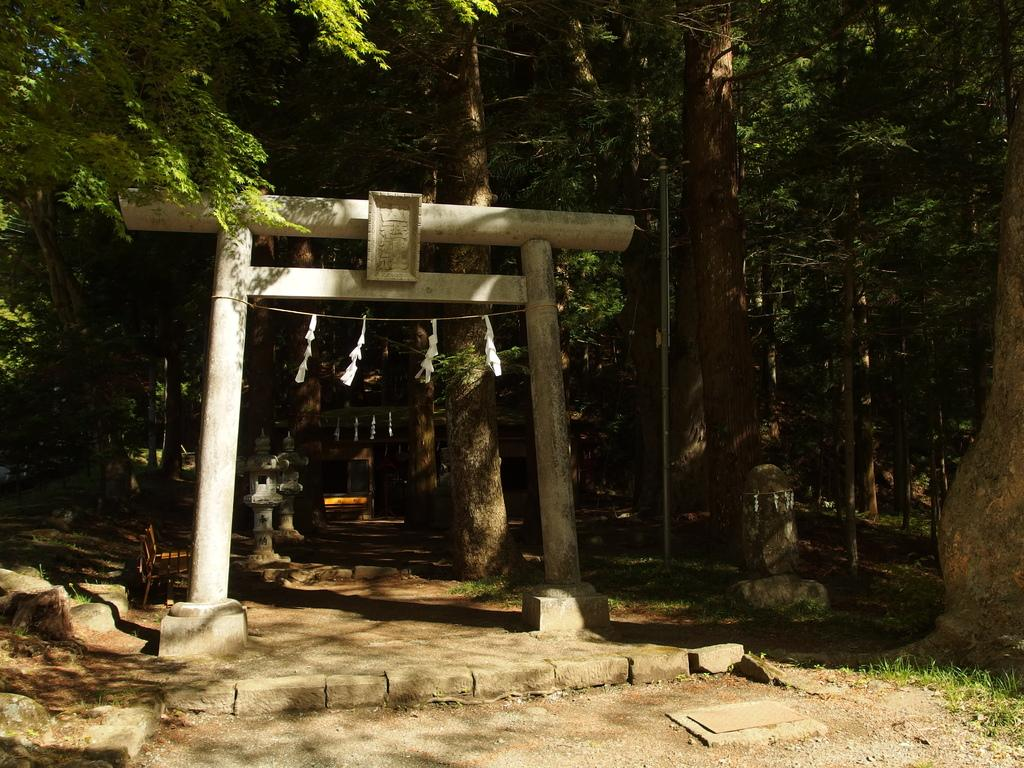What type of structures can be seen in the image? There are poles in the image. What else is present in the image besides the poles? There are objects and trees in the image. What is the ground covered with in the image? There is grass on the ground in the image. What flavor of turkey can be seen in the image? There is no turkey present in the image, so it is not possible to determine its flavor. What type of watch is visible on the tree in the image? There is no watch present in the image; it only features poles, objects, trees, and grass. 